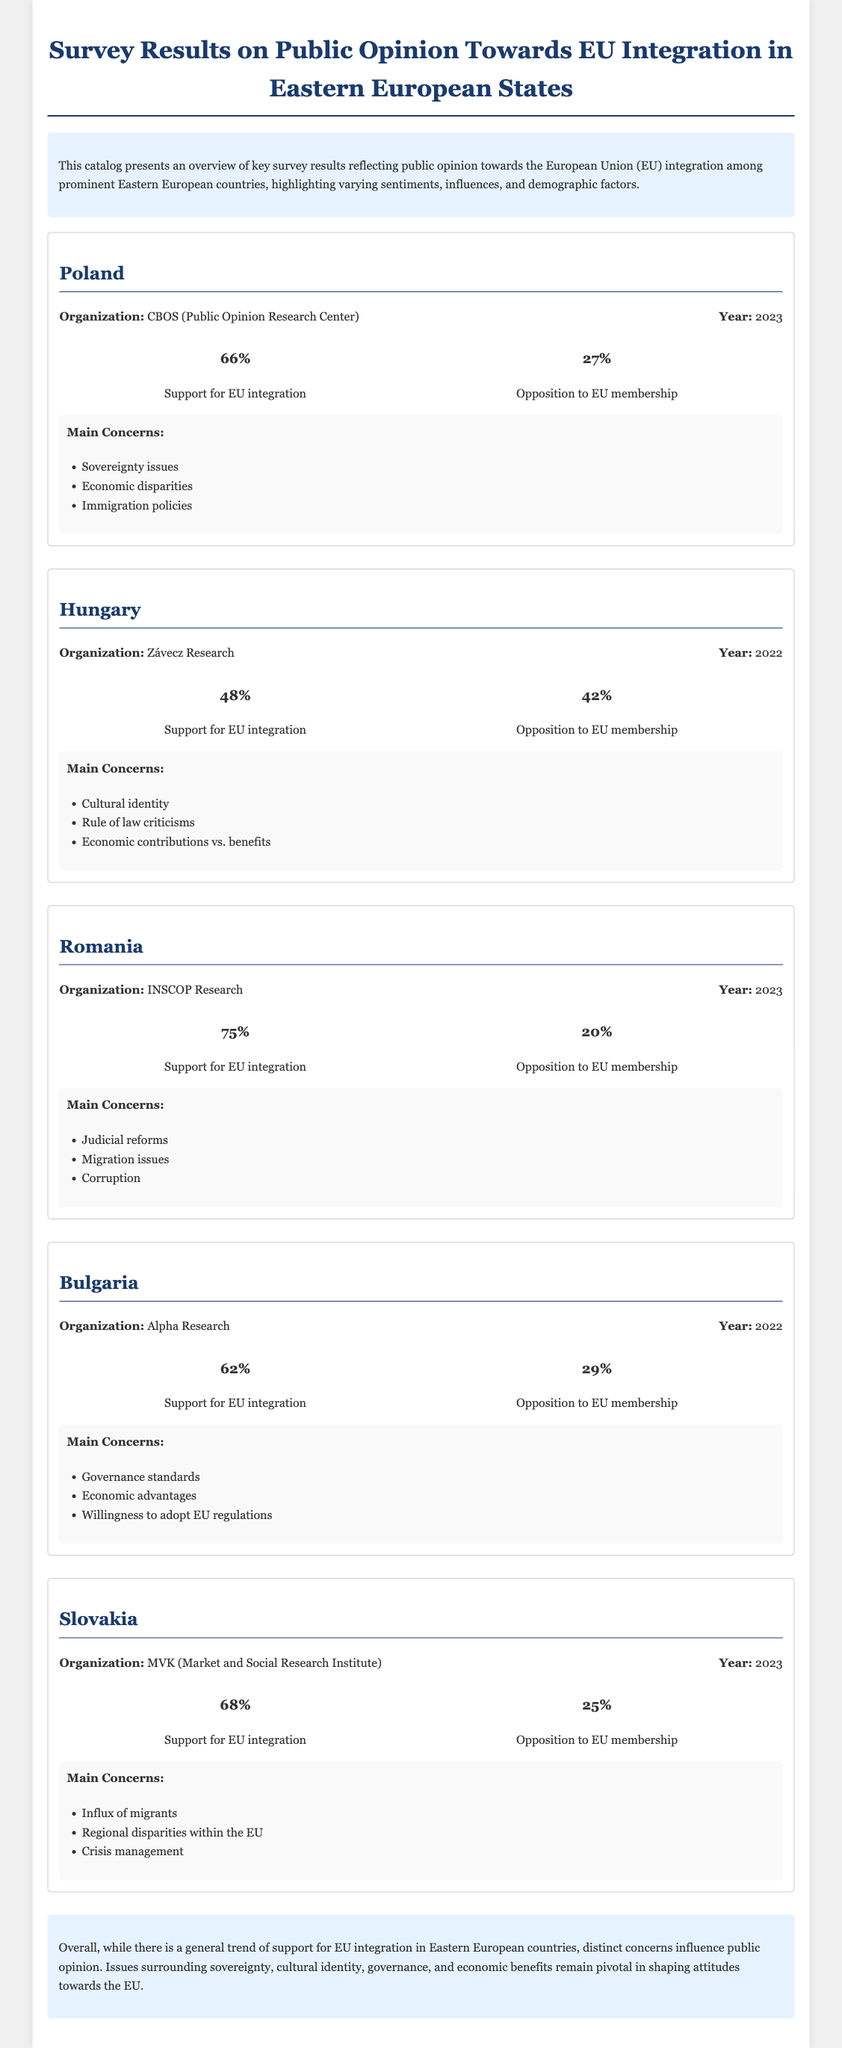What organization conducted the survey in Poland? The survey in Poland was conducted by the Public Opinion Research Center (CBOS).
Answer: CBOS What percentage of Romanians support EU integration? The document states that 75% of Romanians support EU integration.
Answer: 75% What is the main concern regarding EU integration in Hungary? The document lists cultural identity as a main concern regarding EU integration in Hungary.
Answer: Cultural identity What percentage of people oppose EU membership in Bulgaria? According to the survey results, 29% of people in Bulgaria oppose EU membership.
Answer: 29% Which country had the highest percentage of support for EU integration? The results indicate that Romania had the highest percentage of support for EU integration at 75%.
Answer: Romania What year was the survey in Slovakia conducted? The survey in Slovakia was conducted in 2023.
Answer: 2023 Which research organization was responsible for the survey in Romania? The survey in Romania was conducted by INSCOP Research.
Answer: INSCOP Research What are the main concerns related to EU integration in Poland? The main concerns regarding EU integration in Poland include sovereignty issues, economic disparities, and immigration policies.
Answer: Sovereignty issues, economic disparities, immigration policies What percentage of Hungarians oppose EU integration? The document states that 42% of Hungarians oppose EU integration.
Answer: 42% 